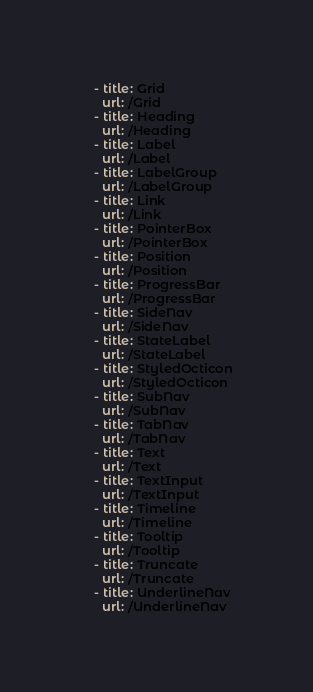Convert code to text. <code><loc_0><loc_0><loc_500><loc_500><_YAML_>    - title: Grid
      url: /Grid
    - title: Heading
      url: /Heading
    - title: Label
      url: /Label
    - title: LabelGroup
      url: /LabelGroup
    - title: Link
      url: /Link
    - title: PointerBox
      url: /PointerBox
    - title: Position
      url: /Position
    - title: ProgressBar
      url: /ProgressBar
    - title: SideNav
      url: /SideNav
    - title: StateLabel
      url: /StateLabel
    - title: StyledOcticon
      url: /StyledOcticon
    - title: SubNav
      url: /SubNav
    - title: TabNav
      url: /TabNav
    - title: Text
      url: /Text
    - title: TextInput
      url: /TextInput
    - title: Timeline
      url: /Timeline
    - title: Tooltip
      url: /Tooltip
    - title: Truncate
      url: /Truncate
    - title: UnderlineNav
      url: /UnderlineNav
</code> 